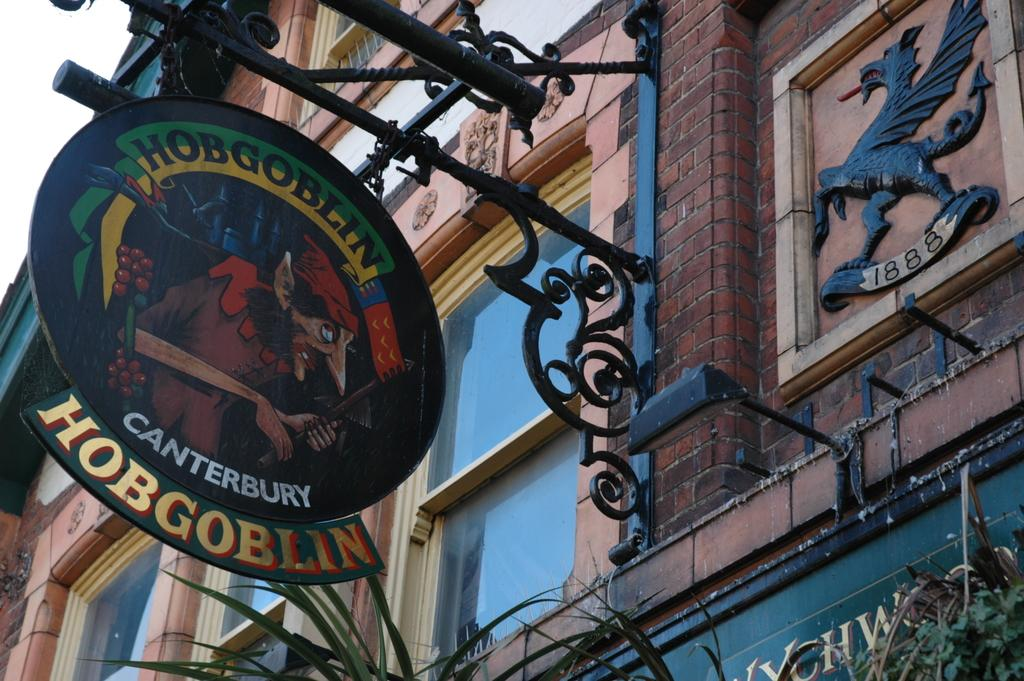What type of structure is visible in the image? There is a building in the image. What feature can be seen on the building? The building has windows. Is there any signage on the building? Yes, there is a name board on the building. What is located below the name board? Plants are present below the name board. What can be seen above the building? The sky is visible above the building. What type of shirt is the building wearing in the image? Buildings do not wear shirts, so this question is not applicable to the image. 